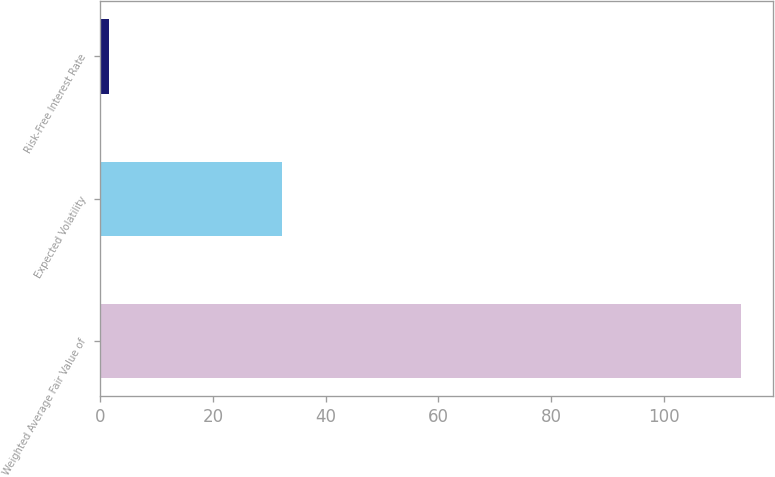Convert chart. <chart><loc_0><loc_0><loc_500><loc_500><bar_chart><fcel>Weighted Average Fair Value of<fcel>Expected Volatility<fcel>Risk-Free Interest Rate<nl><fcel>113.81<fcel>32.19<fcel>1.6<nl></chart> 